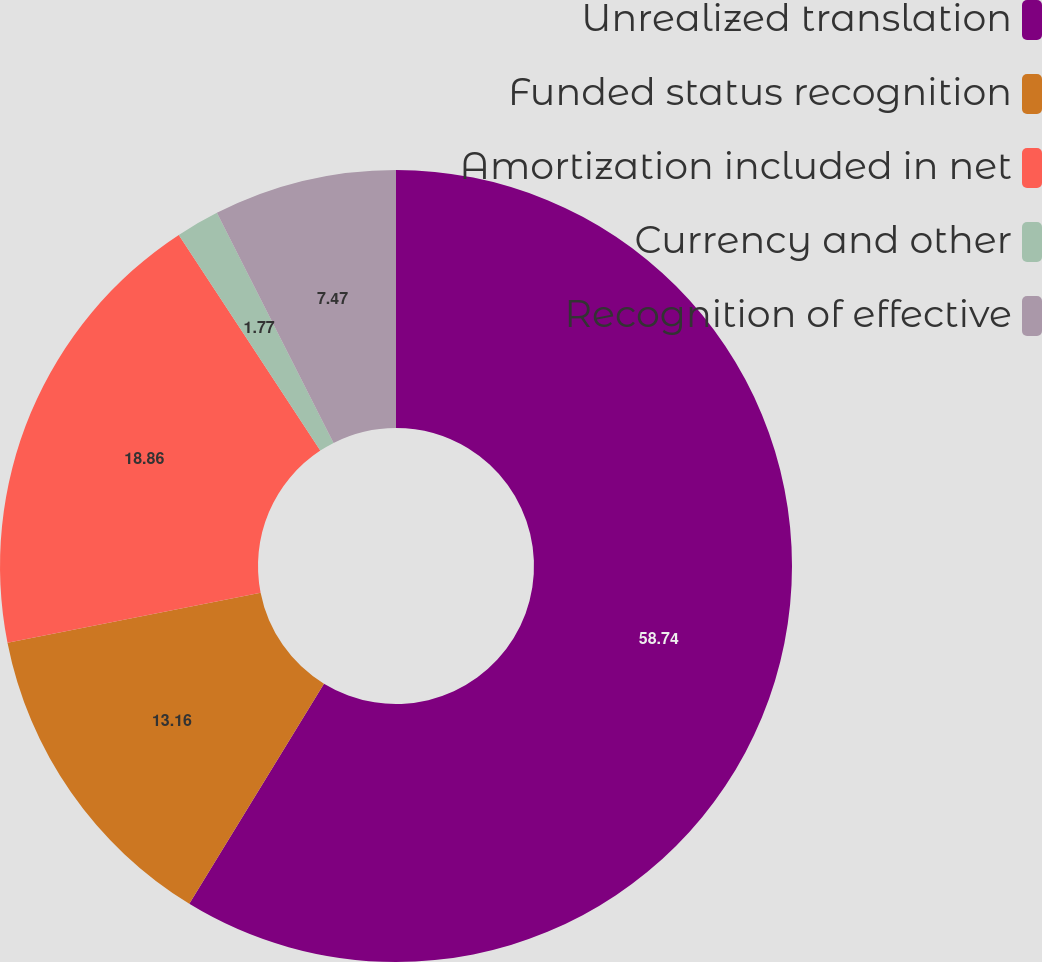<chart> <loc_0><loc_0><loc_500><loc_500><pie_chart><fcel>Unrealized translation<fcel>Funded status recognition<fcel>Amortization included in net<fcel>Currency and other<fcel>Recognition of effective<nl><fcel>58.74%<fcel>13.16%<fcel>18.86%<fcel>1.77%<fcel>7.47%<nl></chart> 